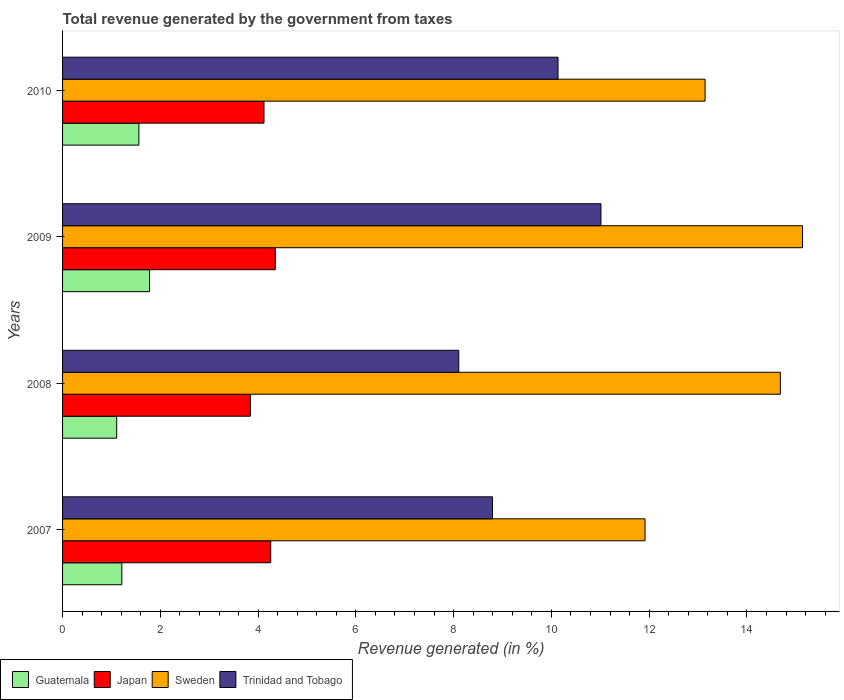How many different coloured bars are there?
Provide a succinct answer. 4. How many groups of bars are there?
Provide a succinct answer. 4. Are the number of bars per tick equal to the number of legend labels?
Your answer should be compact. Yes. Are the number of bars on each tick of the Y-axis equal?
Make the answer very short. Yes. How many bars are there on the 2nd tick from the bottom?
Your answer should be very brief. 4. What is the label of the 4th group of bars from the top?
Ensure brevity in your answer.  2007. What is the total revenue generated in Sweden in 2007?
Your answer should be compact. 11.91. Across all years, what is the maximum total revenue generated in Sweden?
Give a very brief answer. 15.14. Across all years, what is the minimum total revenue generated in Sweden?
Your response must be concise. 11.91. In which year was the total revenue generated in Japan maximum?
Offer a very short reply. 2009. What is the total total revenue generated in Guatemala in the graph?
Offer a terse response. 5.66. What is the difference between the total revenue generated in Sweden in 2007 and that in 2009?
Give a very brief answer. -3.22. What is the difference between the total revenue generated in Japan in 2010 and the total revenue generated in Trinidad and Tobago in 2007?
Your answer should be compact. -4.67. What is the average total revenue generated in Sweden per year?
Keep it short and to the point. 13.72. In the year 2010, what is the difference between the total revenue generated in Sweden and total revenue generated in Japan?
Provide a succinct answer. 9.02. What is the ratio of the total revenue generated in Trinidad and Tobago in 2008 to that in 2009?
Offer a very short reply. 0.74. Is the total revenue generated in Guatemala in 2007 less than that in 2010?
Give a very brief answer. Yes. Is the difference between the total revenue generated in Sweden in 2008 and 2010 greater than the difference between the total revenue generated in Japan in 2008 and 2010?
Offer a terse response. Yes. What is the difference between the highest and the second highest total revenue generated in Japan?
Ensure brevity in your answer.  0.09. What is the difference between the highest and the lowest total revenue generated in Trinidad and Tobago?
Provide a succinct answer. 2.91. What does the 1st bar from the top in 2010 represents?
Your response must be concise. Trinidad and Tobago. What does the 3rd bar from the bottom in 2007 represents?
Your answer should be very brief. Sweden. Is it the case that in every year, the sum of the total revenue generated in Japan and total revenue generated in Trinidad and Tobago is greater than the total revenue generated in Guatemala?
Offer a very short reply. Yes. How many bars are there?
Offer a terse response. 16. Are all the bars in the graph horizontal?
Your answer should be very brief. Yes. Does the graph contain grids?
Keep it short and to the point. No. How are the legend labels stacked?
Offer a terse response. Horizontal. What is the title of the graph?
Give a very brief answer. Total revenue generated by the government from taxes. What is the label or title of the X-axis?
Ensure brevity in your answer.  Revenue generated (in %). What is the Revenue generated (in %) of Guatemala in 2007?
Give a very brief answer. 1.21. What is the Revenue generated (in %) in Japan in 2007?
Provide a succinct answer. 4.26. What is the Revenue generated (in %) of Sweden in 2007?
Offer a very short reply. 11.91. What is the Revenue generated (in %) of Trinidad and Tobago in 2007?
Your answer should be compact. 8.79. What is the Revenue generated (in %) in Guatemala in 2008?
Offer a terse response. 1.11. What is the Revenue generated (in %) in Japan in 2008?
Provide a succinct answer. 3.84. What is the Revenue generated (in %) in Sweden in 2008?
Keep it short and to the point. 14.68. What is the Revenue generated (in %) in Trinidad and Tobago in 2008?
Keep it short and to the point. 8.1. What is the Revenue generated (in %) of Guatemala in 2009?
Provide a succinct answer. 1.78. What is the Revenue generated (in %) of Japan in 2009?
Keep it short and to the point. 4.35. What is the Revenue generated (in %) of Sweden in 2009?
Ensure brevity in your answer.  15.14. What is the Revenue generated (in %) of Trinidad and Tobago in 2009?
Make the answer very short. 11.01. What is the Revenue generated (in %) of Guatemala in 2010?
Your answer should be very brief. 1.56. What is the Revenue generated (in %) in Japan in 2010?
Give a very brief answer. 4.12. What is the Revenue generated (in %) in Sweden in 2010?
Your answer should be very brief. 13.14. What is the Revenue generated (in %) in Trinidad and Tobago in 2010?
Your answer should be compact. 10.13. Across all years, what is the maximum Revenue generated (in %) of Guatemala?
Provide a succinct answer. 1.78. Across all years, what is the maximum Revenue generated (in %) in Japan?
Your response must be concise. 4.35. Across all years, what is the maximum Revenue generated (in %) of Sweden?
Provide a short and direct response. 15.14. Across all years, what is the maximum Revenue generated (in %) in Trinidad and Tobago?
Provide a succinct answer. 11.01. Across all years, what is the minimum Revenue generated (in %) in Guatemala?
Your answer should be compact. 1.11. Across all years, what is the minimum Revenue generated (in %) of Japan?
Your answer should be compact. 3.84. Across all years, what is the minimum Revenue generated (in %) of Sweden?
Make the answer very short. 11.91. Across all years, what is the minimum Revenue generated (in %) in Trinidad and Tobago?
Make the answer very short. 8.1. What is the total Revenue generated (in %) of Guatemala in the graph?
Provide a succinct answer. 5.66. What is the total Revenue generated (in %) of Japan in the graph?
Your answer should be compact. 16.57. What is the total Revenue generated (in %) in Sweden in the graph?
Offer a terse response. 54.88. What is the total Revenue generated (in %) of Trinidad and Tobago in the graph?
Your answer should be very brief. 38.05. What is the difference between the Revenue generated (in %) of Guatemala in 2007 and that in 2008?
Your answer should be compact. 0.11. What is the difference between the Revenue generated (in %) in Japan in 2007 and that in 2008?
Make the answer very short. 0.42. What is the difference between the Revenue generated (in %) of Sweden in 2007 and that in 2008?
Keep it short and to the point. -2.77. What is the difference between the Revenue generated (in %) of Trinidad and Tobago in 2007 and that in 2008?
Your answer should be very brief. 0.69. What is the difference between the Revenue generated (in %) in Guatemala in 2007 and that in 2009?
Offer a terse response. -0.57. What is the difference between the Revenue generated (in %) in Japan in 2007 and that in 2009?
Offer a terse response. -0.09. What is the difference between the Revenue generated (in %) in Sweden in 2007 and that in 2009?
Offer a terse response. -3.22. What is the difference between the Revenue generated (in %) in Trinidad and Tobago in 2007 and that in 2009?
Provide a short and direct response. -2.22. What is the difference between the Revenue generated (in %) in Guatemala in 2007 and that in 2010?
Offer a very short reply. -0.35. What is the difference between the Revenue generated (in %) in Japan in 2007 and that in 2010?
Your answer should be compact. 0.14. What is the difference between the Revenue generated (in %) of Sweden in 2007 and that in 2010?
Offer a terse response. -1.23. What is the difference between the Revenue generated (in %) in Trinidad and Tobago in 2007 and that in 2010?
Ensure brevity in your answer.  -1.34. What is the difference between the Revenue generated (in %) of Guatemala in 2008 and that in 2009?
Offer a very short reply. -0.67. What is the difference between the Revenue generated (in %) in Japan in 2008 and that in 2009?
Make the answer very short. -0.51. What is the difference between the Revenue generated (in %) of Sweden in 2008 and that in 2009?
Keep it short and to the point. -0.45. What is the difference between the Revenue generated (in %) in Trinidad and Tobago in 2008 and that in 2009?
Your answer should be compact. -2.91. What is the difference between the Revenue generated (in %) in Guatemala in 2008 and that in 2010?
Provide a short and direct response. -0.45. What is the difference between the Revenue generated (in %) of Japan in 2008 and that in 2010?
Your response must be concise. -0.28. What is the difference between the Revenue generated (in %) in Sweden in 2008 and that in 2010?
Provide a succinct answer. 1.54. What is the difference between the Revenue generated (in %) in Trinidad and Tobago in 2008 and that in 2010?
Provide a succinct answer. -2.03. What is the difference between the Revenue generated (in %) in Guatemala in 2009 and that in 2010?
Keep it short and to the point. 0.22. What is the difference between the Revenue generated (in %) in Japan in 2009 and that in 2010?
Ensure brevity in your answer.  0.23. What is the difference between the Revenue generated (in %) in Sweden in 2009 and that in 2010?
Provide a short and direct response. 1.99. What is the difference between the Revenue generated (in %) in Trinidad and Tobago in 2009 and that in 2010?
Provide a succinct answer. 0.88. What is the difference between the Revenue generated (in %) in Guatemala in 2007 and the Revenue generated (in %) in Japan in 2008?
Provide a short and direct response. -2.63. What is the difference between the Revenue generated (in %) of Guatemala in 2007 and the Revenue generated (in %) of Sweden in 2008?
Your response must be concise. -13.47. What is the difference between the Revenue generated (in %) in Guatemala in 2007 and the Revenue generated (in %) in Trinidad and Tobago in 2008?
Make the answer very short. -6.89. What is the difference between the Revenue generated (in %) in Japan in 2007 and the Revenue generated (in %) in Sweden in 2008?
Your response must be concise. -10.43. What is the difference between the Revenue generated (in %) of Japan in 2007 and the Revenue generated (in %) of Trinidad and Tobago in 2008?
Your answer should be compact. -3.85. What is the difference between the Revenue generated (in %) of Sweden in 2007 and the Revenue generated (in %) of Trinidad and Tobago in 2008?
Keep it short and to the point. 3.81. What is the difference between the Revenue generated (in %) of Guatemala in 2007 and the Revenue generated (in %) of Japan in 2009?
Offer a terse response. -3.14. What is the difference between the Revenue generated (in %) in Guatemala in 2007 and the Revenue generated (in %) in Sweden in 2009?
Provide a short and direct response. -13.92. What is the difference between the Revenue generated (in %) of Guatemala in 2007 and the Revenue generated (in %) of Trinidad and Tobago in 2009?
Provide a short and direct response. -9.8. What is the difference between the Revenue generated (in %) of Japan in 2007 and the Revenue generated (in %) of Sweden in 2009?
Offer a terse response. -10.88. What is the difference between the Revenue generated (in %) of Japan in 2007 and the Revenue generated (in %) of Trinidad and Tobago in 2009?
Your answer should be very brief. -6.76. What is the difference between the Revenue generated (in %) in Sweden in 2007 and the Revenue generated (in %) in Trinidad and Tobago in 2009?
Make the answer very short. 0.9. What is the difference between the Revenue generated (in %) in Guatemala in 2007 and the Revenue generated (in %) in Japan in 2010?
Offer a terse response. -2.91. What is the difference between the Revenue generated (in %) in Guatemala in 2007 and the Revenue generated (in %) in Sweden in 2010?
Provide a succinct answer. -11.93. What is the difference between the Revenue generated (in %) of Guatemala in 2007 and the Revenue generated (in %) of Trinidad and Tobago in 2010?
Your answer should be very brief. -8.92. What is the difference between the Revenue generated (in %) of Japan in 2007 and the Revenue generated (in %) of Sweden in 2010?
Offer a terse response. -8.89. What is the difference between the Revenue generated (in %) of Japan in 2007 and the Revenue generated (in %) of Trinidad and Tobago in 2010?
Provide a succinct answer. -5.88. What is the difference between the Revenue generated (in %) of Sweden in 2007 and the Revenue generated (in %) of Trinidad and Tobago in 2010?
Your answer should be compact. 1.78. What is the difference between the Revenue generated (in %) of Guatemala in 2008 and the Revenue generated (in %) of Japan in 2009?
Offer a terse response. -3.24. What is the difference between the Revenue generated (in %) in Guatemala in 2008 and the Revenue generated (in %) in Sweden in 2009?
Give a very brief answer. -14.03. What is the difference between the Revenue generated (in %) of Guatemala in 2008 and the Revenue generated (in %) of Trinidad and Tobago in 2009?
Give a very brief answer. -9.91. What is the difference between the Revenue generated (in %) of Japan in 2008 and the Revenue generated (in %) of Sweden in 2009?
Give a very brief answer. -11.29. What is the difference between the Revenue generated (in %) of Japan in 2008 and the Revenue generated (in %) of Trinidad and Tobago in 2009?
Your answer should be very brief. -7.17. What is the difference between the Revenue generated (in %) of Sweden in 2008 and the Revenue generated (in %) of Trinidad and Tobago in 2009?
Provide a short and direct response. 3.67. What is the difference between the Revenue generated (in %) of Guatemala in 2008 and the Revenue generated (in %) of Japan in 2010?
Your answer should be very brief. -3.01. What is the difference between the Revenue generated (in %) in Guatemala in 2008 and the Revenue generated (in %) in Sweden in 2010?
Ensure brevity in your answer.  -12.04. What is the difference between the Revenue generated (in %) of Guatemala in 2008 and the Revenue generated (in %) of Trinidad and Tobago in 2010?
Ensure brevity in your answer.  -9.03. What is the difference between the Revenue generated (in %) of Japan in 2008 and the Revenue generated (in %) of Sweden in 2010?
Your response must be concise. -9.3. What is the difference between the Revenue generated (in %) of Japan in 2008 and the Revenue generated (in %) of Trinidad and Tobago in 2010?
Offer a very short reply. -6.29. What is the difference between the Revenue generated (in %) in Sweden in 2008 and the Revenue generated (in %) in Trinidad and Tobago in 2010?
Provide a succinct answer. 4.55. What is the difference between the Revenue generated (in %) in Guatemala in 2009 and the Revenue generated (in %) in Japan in 2010?
Offer a very short reply. -2.34. What is the difference between the Revenue generated (in %) in Guatemala in 2009 and the Revenue generated (in %) in Sweden in 2010?
Ensure brevity in your answer.  -11.36. What is the difference between the Revenue generated (in %) in Guatemala in 2009 and the Revenue generated (in %) in Trinidad and Tobago in 2010?
Your response must be concise. -8.36. What is the difference between the Revenue generated (in %) of Japan in 2009 and the Revenue generated (in %) of Sweden in 2010?
Provide a short and direct response. -8.79. What is the difference between the Revenue generated (in %) of Japan in 2009 and the Revenue generated (in %) of Trinidad and Tobago in 2010?
Keep it short and to the point. -5.78. What is the difference between the Revenue generated (in %) of Sweden in 2009 and the Revenue generated (in %) of Trinidad and Tobago in 2010?
Your response must be concise. 5. What is the average Revenue generated (in %) in Guatemala per year?
Your answer should be compact. 1.41. What is the average Revenue generated (in %) in Japan per year?
Offer a terse response. 4.14. What is the average Revenue generated (in %) in Sweden per year?
Provide a short and direct response. 13.72. What is the average Revenue generated (in %) of Trinidad and Tobago per year?
Keep it short and to the point. 9.51. In the year 2007, what is the difference between the Revenue generated (in %) in Guatemala and Revenue generated (in %) in Japan?
Make the answer very short. -3.05. In the year 2007, what is the difference between the Revenue generated (in %) of Guatemala and Revenue generated (in %) of Sweden?
Provide a succinct answer. -10.7. In the year 2007, what is the difference between the Revenue generated (in %) of Guatemala and Revenue generated (in %) of Trinidad and Tobago?
Ensure brevity in your answer.  -7.58. In the year 2007, what is the difference between the Revenue generated (in %) in Japan and Revenue generated (in %) in Sweden?
Give a very brief answer. -7.66. In the year 2007, what is the difference between the Revenue generated (in %) in Japan and Revenue generated (in %) in Trinidad and Tobago?
Your answer should be very brief. -4.54. In the year 2007, what is the difference between the Revenue generated (in %) of Sweden and Revenue generated (in %) of Trinidad and Tobago?
Give a very brief answer. 3.12. In the year 2008, what is the difference between the Revenue generated (in %) of Guatemala and Revenue generated (in %) of Japan?
Your response must be concise. -2.73. In the year 2008, what is the difference between the Revenue generated (in %) in Guatemala and Revenue generated (in %) in Sweden?
Offer a very short reply. -13.58. In the year 2008, what is the difference between the Revenue generated (in %) of Guatemala and Revenue generated (in %) of Trinidad and Tobago?
Keep it short and to the point. -7. In the year 2008, what is the difference between the Revenue generated (in %) in Japan and Revenue generated (in %) in Sweden?
Offer a very short reply. -10.84. In the year 2008, what is the difference between the Revenue generated (in %) of Japan and Revenue generated (in %) of Trinidad and Tobago?
Make the answer very short. -4.26. In the year 2008, what is the difference between the Revenue generated (in %) of Sweden and Revenue generated (in %) of Trinidad and Tobago?
Offer a very short reply. 6.58. In the year 2009, what is the difference between the Revenue generated (in %) of Guatemala and Revenue generated (in %) of Japan?
Make the answer very short. -2.57. In the year 2009, what is the difference between the Revenue generated (in %) of Guatemala and Revenue generated (in %) of Sweden?
Provide a succinct answer. -13.36. In the year 2009, what is the difference between the Revenue generated (in %) of Guatemala and Revenue generated (in %) of Trinidad and Tobago?
Make the answer very short. -9.23. In the year 2009, what is the difference between the Revenue generated (in %) of Japan and Revenue generated (in %) of Sweden?
Your response must be concise. -10.79. In the year 2009, what is the difference between the Revenue generated (in %) of Japan and Revenue generated (in %) of Trinidad and Tobago?
Your answer should be very brief. -6.66. In the year 2009, what is the difference between the Revenue generated (in %) in Sweden and Revenue generated (in %) in Trinidad and Tobago?
Offer a terse response. 4.12. In the year 2010, what is the difference between the Revenue generated (in %) in Guatemala and Revenue generated (in %) in Japan?
Provide a succinct answer. -2.56. In the year 2010, what is the difference between the Revenue generated (in %) in Guatemala and Revenue generated (in %) in Sweden?
Give a very brief answer. -11.58. In the year 2010, what is the difference between the Revenue generated (in %) of Guatemala and Revenue generated (in %) of Trinidad and Tobago?
Your answer should be compact. -8.57. In the year 2010, what is the difference between the Revenue generated (in %) of Japan and Revenue generated (in %) of Sweden?
Make the answer very short. -9.02. In the year 2010, what is the difference between the Revenue generated (in %) in Japan and Revenue generated (in %) in Trinidad and Tobago?
Keep it short and to the point. -6.01. In the year 2010, what is the difference between the Revenue generated (in %) of Sweden and Revenue generated (in %) of Trinidad and Tobago?
Offer a very short reply. 3.01. What is the ratio of the Revenue generated (in %) in Guatemala in 2007 to that in 2008?
Keep it short and to the point. 1.1. What is the ratio of the Revenue generated (in %) in Japan in 2007 to that in 2008?
Make the answer very short. 1.11. What is the ratio of the Revenue generated (in %) of Sweden in 2007 to that in 2008?
Ensure brevity in your answer.  0.81. What is the ratio of the Revenue generated (in %) in Trinidad and Tobago in 2007 to that in 2008?
Ensure brevity in your answer.  1.09. What is the ratio of the Revenue generated (in %) in Guatemala in 2007 to that in 2009?
Ensure brevity in your answer.  0.68. What is the ratio of the Revenue generated (in %) in Japan in 2007 to that in 2009?
Your answer should be compact. 0.98. What is the ratio of the Revenue generated (in %) in Sweden in 2007 to that in 2009?
Provide a short and direct response. 0.79. What is the ratio of the Revenue generated (in %) of Trinidad and Tobago in 2007 to that in 2009?
Ensure brevity in your answer.  0.8. What is the ratio of the Revenue generated (in %) of Guatemala in 2007 to that in 2010?
Offer a very short reply. 0.78. What is the ratio of the Revenue generated (in %) in Japan in 2007 to that in 2010?
Give a very brief answer. 1.03. What is the ratio of the Revenue generated (in %) in Sweden in 2007 to that in 2010?
Make the answer very short. 0.91. What is the ratio of the Revenue generated (in %) of Trinidad and Tobago in 2007 to that in 2010?
Your response must be concise. 0.87. What is the ratio of the Revenue generated (in %) in Guatemala in 2008 to that in 2009?
Ensure brevity in your answer.  0.62. What is the ratio of the Revenue generated (in %) of Japan in 2008 to that in 2009?
Offer a terse response. 0.88. What is the ratio of the Revenue generated (in %) of Sweden in 2008 to that in 2009?
Give a very brief answer. 0.97. What is the ratio of the Revenue generated (in %) in Trinidad and Tobago in 2008 to that in 2009?
Offer a very short reply. 0.74. What is the ratio of the Revenue generated (in %) in Guatemala in 2008 to that in 2010?
Provide a succinct answer. 0.71. What is the ratio of the Revenue generated (in %) in Japan in 2008 to that in 2010?
Provide a short and direct response. 0.93. What is the ratio of the Revenue generated (in %) of Sweden in 2008 to that in 2010?
Your response must be concise. 1.12. What is the ratio of the Revenue generated (in %) in Trinidad and Tobago in 2008 to that in 2010?
Give a very brief answer. 0.8. What is the ratio of the Revenue generated (in %) in Guatemala in 2009 to that in 2010?
Make the answer very short. 1.14. What is the ratio of the Revenue generated (in %) in Japan in 2009 to that in 2010?
Offer a very short reply. 1.06. What is the ratio of the Revenue generated (in %) in Sweden in 2009 to that in 2010?
Your answer should be compact. 1.15. What is the ratio of the Revenue generated (in %) in Trinidad and Tobago in 2009 to that in 2010?
Make the answer very short. 1.09. What is the difference between the highest and the second highest Revenue generated (in %) in Guatemala?
Give a very brief answer. 0.22. What is the difference between the highest and the second highest Revenue generated (in %) in Japan?
Offer a terse response. 0.09. What is the difference between the highest and the second highest Revenue generated (in %) in Sweden?
Offer a very short reply. 0.45. What is the difference between the highest and the second highest Revenue generated (in %) of Trinidad and Tobago?
Offer a terse response. 0.88. What is the difference between the highest and the lowest Revenue generated (in %) in Guatemala?
Your response must be concise. 0.67. What is the difference between the highest and the lowest Revenue generated (in %) of Japan?
Keep it short and to the point. 0.51. What is the difference between the highest and the lowest Revenue generated (in %) in Sweden?
Provide a short and direct response. 3.22. What is the difference between the highest and the lowest Revenue generated (in %) in Trinidad and Tobago?
Keep it short and to the point. 2.91. 